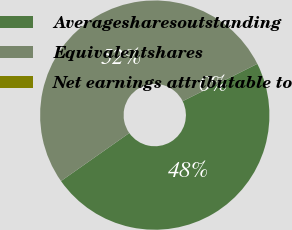Convert chart. <chart><loc_0><loc_0><loc_500><loc_500><pie_chart><fcel>Averagesharesoutstanding<fcel>Equivalentshares<fcel>Net earnings attributable to<nl><fcel>47.62%<fcel>52.38%<fcel>0.0%<nl></chart> 